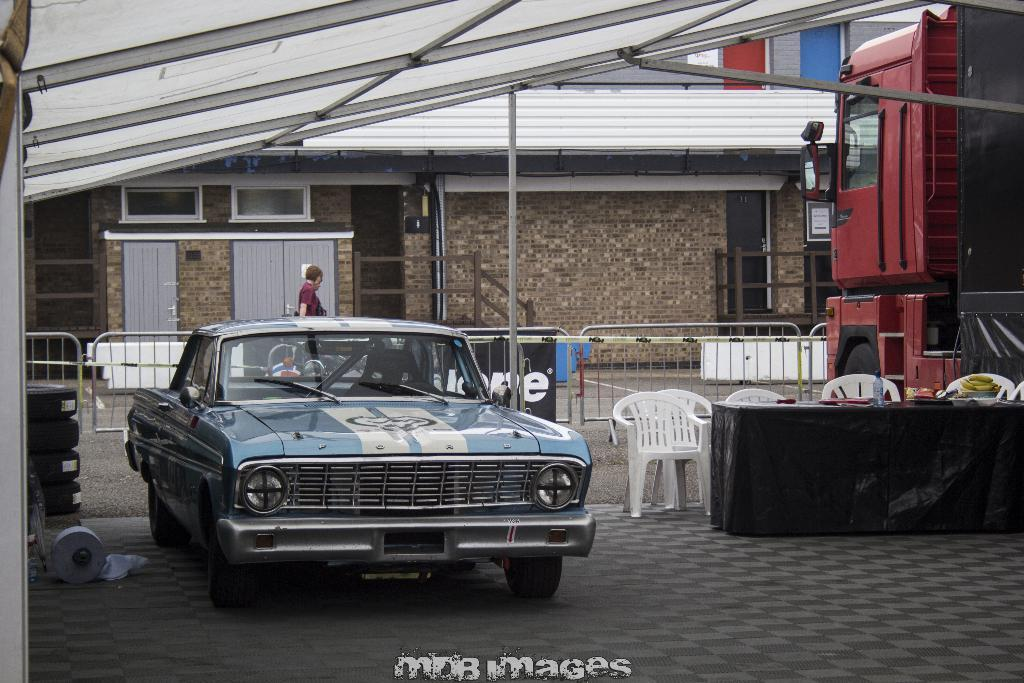What is the main subject of the image? The main subject of the image is a person walking. Where is the person walking? The person is walking on a walkway. What else can be seen in the image? There is a car parked beside the walkway in the image. What question is the person asking their brother in the image? There is no indication in the image that the person is asking a question or has a brother. 